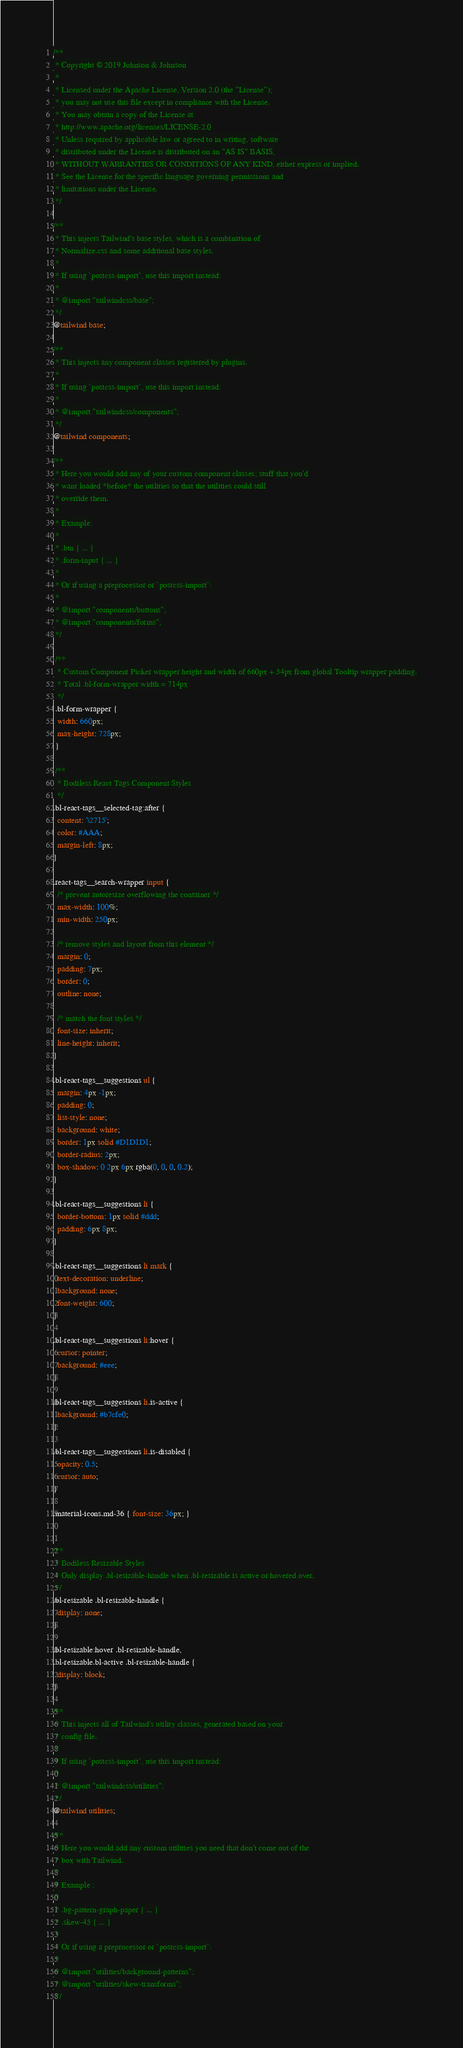<code> <loc_0><loc_0><loc_500><loc_500><_CSS_>/**
 * Copyright © 2019 Johnson & Johnson
 *
 * Licensed under the Apache License, Version 2.0 (the "License");
 * you may not use this file except in compliance with the License.
 * You may obtain a copy of the License at
 * http://www.apache.org/licenses/LICENSE-2.0
 * Unless required by applicable law or agreed to in writing, software
 * distributed under the License is distributed on an "AS IS" BASIS,
 * WITHOUT WARRANTIES OR CONDITIONS OF ANY KIND, either express or implied.
 * See the License for the specific language governing permissions and
 * limitations under the License.
 */

/**
 * This injects Tailwind's base styles, which is a combination of
 * Normalize.css and some additional base styles.
 *
 * If using `postcss-import`, use this import instead:
 *
 * @import "tailwindcss/base";
 */
@tailwind base;

/**
 * This injects any component classes registered by plugins.
 *
 * If using `postcss-import`, use this import instead:
 *
 * @import "tailwindcss/components";
 */
@tailwind components;

/**
 * Here you would add any of your custom component classes; stuff that you'd
 * want loaded *before* the utilities so that the utilities could still
 * override them.
 *
 * Example:
 *
 * .btn { ... }
 * .form-input { ... }
 *
 * Or if using a preprocessor or `postcss-import`:
 *
 * @import "components/buttons";
 * @import "components/forms";
 */

 /**
  * Custom Component Picker wrapper height and width of 660px + 54px from global Tooltip wrapper padding.
  * Total .bl-form-wrapper width = 714px
  */
 .bl-form-wrapper {
  width: 660px;
  max-height: 728px;
 }

 /**
  * Bodiless React Tags Component Styles
  */
.bl-react-tags__selected-tag:after {
  content: '\2715';
  color: #AAA;
  margin-left: 8px;
}

.react-tags__search-wrapper input {
  /* prevent autoresize overflowing the container */
  max-width: 100%;
  min-width: 250px;

  /* remove styles and layout from this element */
  margin: 0;
  padding: 7px;
  border: 0;
  outline: none;

  /* match the font styles */
  font-size: inherit;
  line-height: inherit;
}

.bl-react-tags__suggestions ul {
  margin: 4px -1px;
  padding: 0;
  list-style: none;
  background: white;
  border: 1px solid #D1D1D1;
  border-radius: 2px;
  box-shadow: 0 2px 6px rgba(0, 0, 0, 0.2);
}

.bl-react-tags__suggestions li {
  border-bottom: 1px solid #ddd;
  padding: 6px 8px;
}

.bl-react-tags__suggestions li mark {
  text-decoration: underline;
  background: none;
  font-weight: 600;
}

.bl-react-tags__suggestions li:hover {
  cursor: pointer;
  background: #eee;
}

.bl-react-tags__suggestions li.is-active {
  background: #b7cfe0;
}

.bl-react-tags__suggestions li.is-disabled {
  opacity: 0.5;
  cursor: auto;
}

.material-icons.md-36 { font-size: 36px; }


/**
 * Bodiless Resizable Styles
 * Only display .bl-resizable-handle when .bl-resizable is active or hovered over.
 */
.bl-resizable .bl-resizable-handle {
  display: none;
}

.bl-resizable:hover .bl-resizable-handle,
.bl-resizable.bl-active .bl-resizable-handle {
  display: block;
}

/**
 * This injects all of Tailwind's utility classes, generated based on your
 * config file.
 *
 * If using `postcss-import`, use this import instead:
 *
 * @import "tailwindcss/utilities";
 */
@tailwind utilities;

/**
 * Here you would add any custom utilities you need that don't come out of the
 * box with Tailwind.
 *
 * Example :
 *
 * .bg-pattern-graph-paper { ... }
 * .skew-45 { ... }
 *
 * Or if using a preprocessor or `postcss-import`:
 *
 * @import "utilities/background-patterns";
 * @import "utilities/skew-transforms";
 */
</code> 